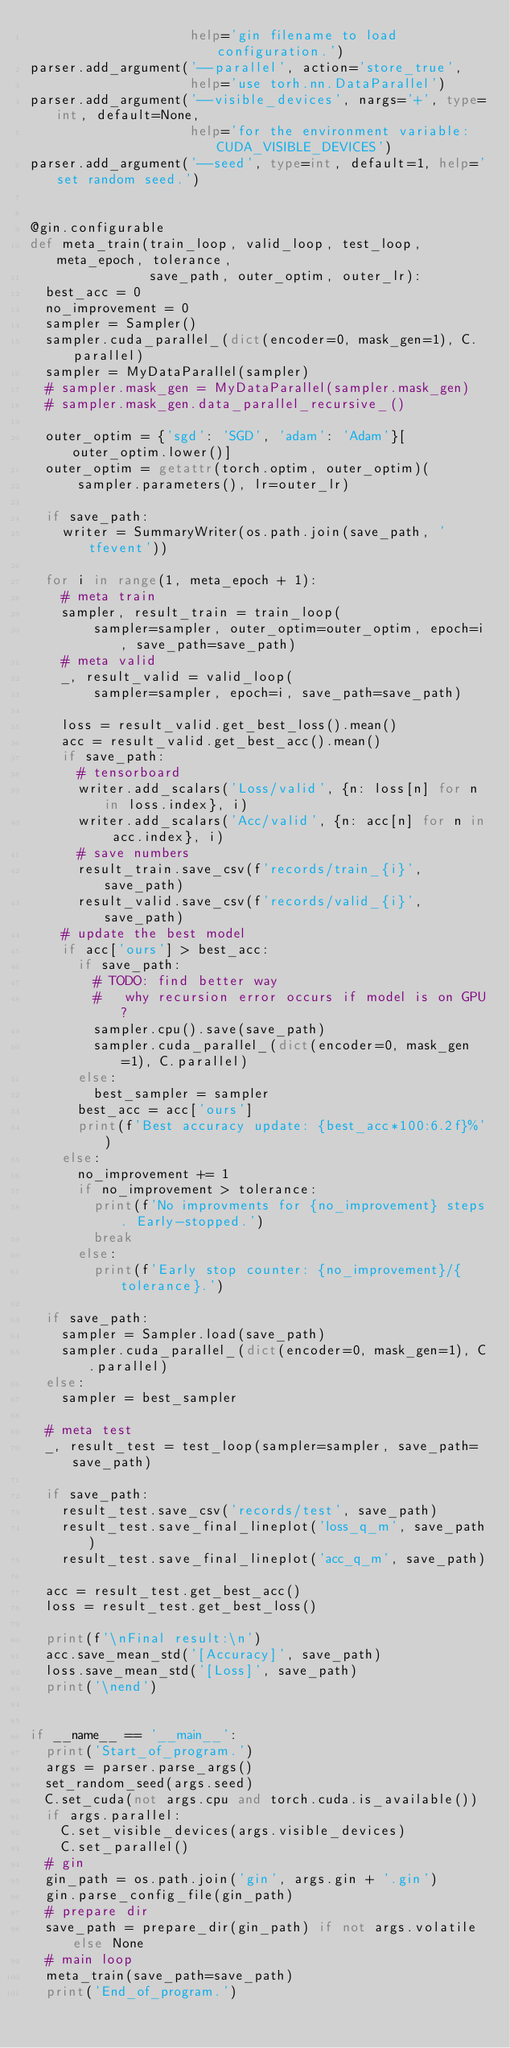Convert code to text. <code><loc_0><loc_0><loc_500><loc_500><_Python_>                    help='gin filename to load configuration.')
parser.add_argument('--parallel', action='store_true',
                    help='use torh.nn.DataParallel')
parser.add_argument('--visible_devices', nargs='+', type=int, default=None,
                    help='for the environment variable: CUDA_VISIBLE_DEVICES')
parser.add_argument('--seed', type=int, default=1, help='set random seed.')


@gin.configurable
def meta_train(train_loop, valid_loop, test_loop, meta_epoch, tolerance,
               save_path, outer_optim, outer_lr):
  best_acc = 0
  no_improvement = 0
  sampler = Sampler()
  sampler.cuda_parallel_(dict(encoder=0, mask_gen=1), C.parallel)
  sampler = MyDataParallel(sampler)
  # sampler.mask_gen = MyDataParallel(sampler.mask_gen)
  # sampler.mask_gen.data_parallel_recursive_()

  outer_optim = {'sgd': 'SGD', 'adam': 'Adam'}[outer_optim.lower()]
  outer_optim = getattr(torch.optim, outer_optim)(
      sampler.parameters(), lr=outer_lr)

  if save_path:
    writer = SummaryWriter(os.path.join(save_path, 'tfevent'))

  for i in range(1, meta_epoch + 1):
    # meta train
    sampler, result_train = train_loop(
        sampler=sampler, outer_optim=outer_optim, epoch=i, save_path=save_path)
    # meta valid
    _, result_valid = valid_loop(
        sampler=sampler, epoch=i, save_path=save_path)

    loss = result_valid.get_best_loss().mean()
    acc = result_valid.get_best_acc().mean()
    if save_path:
      # tensorboard
      writer.add_scalars('Loss/valid', {n: loss[n] for n in loss.index}, i)
      writer.add_scalars('Acc/valid', {n: acc[n] for n in acc.index}, i)
      # save numbers
      result_train.save_csv(f'records/train_{i}', save_path)
      result_valid.save_csv(f'records/valid_{i}', save_path)
    # update the best model
    if acc['ours'] > best_acc:
      if save_path:
        # TODO: find better way
        #   why recursion error occurs if model is on GPU?
        sampler.cpu().save(save_path)
        sampler.cuda_parallel_(dict(encoder=0, mask_gen=1), C.parallel)
      else:
        best_sampler = sampler
      best_acc = acc['ours']
      print(f'Best accuracy update: {best_acc*100:6.2f}%')
    else:
      no_improvement += 1
      if no_improvement > tolerance:
        print(f'No improvments for {no_improvement} steps. Early-stopped.')
        break
      else:
        print(f'Early stop counter: {no_improvement}/{tolerance}.')

  if save_path:
    sampler = Sampler.load(save_path)
    sampler.cuda_parallel_(dict(encoder=0, mask_gen=1), C.parallel)
  else:
    sampler = best_sampler

  # meta test
  _, result_test = test_loop(sampler=sampler, save_path=save_path)

  if save_path:
    result_test.save_csv('records/test', save_path)
    result_test.save_final_lineplot('loss_q_m', save_path)
    result_test.save_final_lineplot('acc_q_m', save_path)

  acc = result_test.get_best_acc()
  loss = result_test.get_best_loss()

  print(f'\nFinal result:\n')
  acc.save_mean_std('[Accuracy]', save_path)
  loss.save_mean_std('[Loss]', save_path)
  print('\nend')


if __name__ == '__main__':
  print('Start_of_program.')
  args = parser.parse_args()
  set_random_seed(args.seed)
  C.set_cuda(not args.cpu and torch.cuda.is_available())
  if args.parallel:
    C.set_visible_devices(args.visible_devices)
    C.set_parallel()
  # gin
  gin_path = os.path.join('gin', args.gin + '.gin')
  gin.parse_config_file(gin_path)
  # prepare dir
  save_path = prepare_dir(gin_path) if not args.volatile else None
  # main loop
  meta_train(save_path=save_path)
  print('End_of_program.')
</code> 